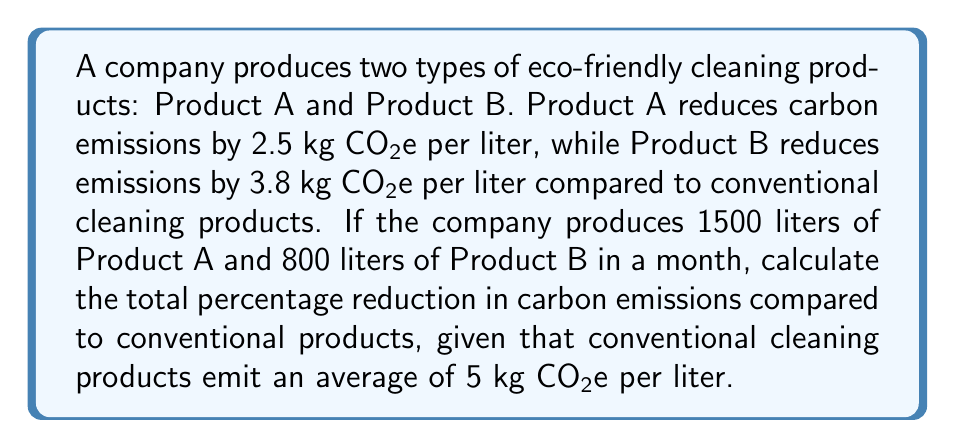Teach me how to tackle this problem. Let's approach this problem step-by-step:

1. Calculate the total carbon emissions from conventional products:
   - Total volume = 1500 L (A) + 800 L (B) = 2300 L
   - Emissions per liter = 5 kg CO₂e/L
   - Total conventional emissions = $2300 \times 5 = 11500$ kg CO₂e

2. Calculate the reduced emissions for each product:
   - Product A: $1500 \times 2.5 = 3750$ kg CO₂e
   - Product B: $800 \times 3.8 = 3040$ kg CO₂e
   - Total reduced emissions = $3750 + 3040 = 6790$ kg CO₂e

3. Calculate the actual emissions from eco-friendly products:
   - Actual emissions = Total conventional - Total reduced
   - $11500 - 6790 = 4710$ kg CO₂e

4. Calculate the percentage reduction:
   $$\text{Percentage reduction} = \frac{\text{Reduced emissions}}{\text{Total conventional emissions}} \times 100\%$$
   
   $$= \frac{6790}{11500} \times 100\% = 0.5904 \times 100\% = 59.04\%$$

Thus, the total percentage reduction in carbon emissions is approximately 59.04%.
Answer: 59.04% 